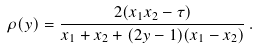<formula> <loc_0><loc_0><loc_500><loc_500>\rho ( y ) = \frac { 2 ( x _ { 1 } x _ { 2 } - \tau ) } { x _ { 1 } + x _ { 2 } + ( 2 y - 1 ) ( x _ { 1 } - x _ { 2 } ) } \, .</formula> 